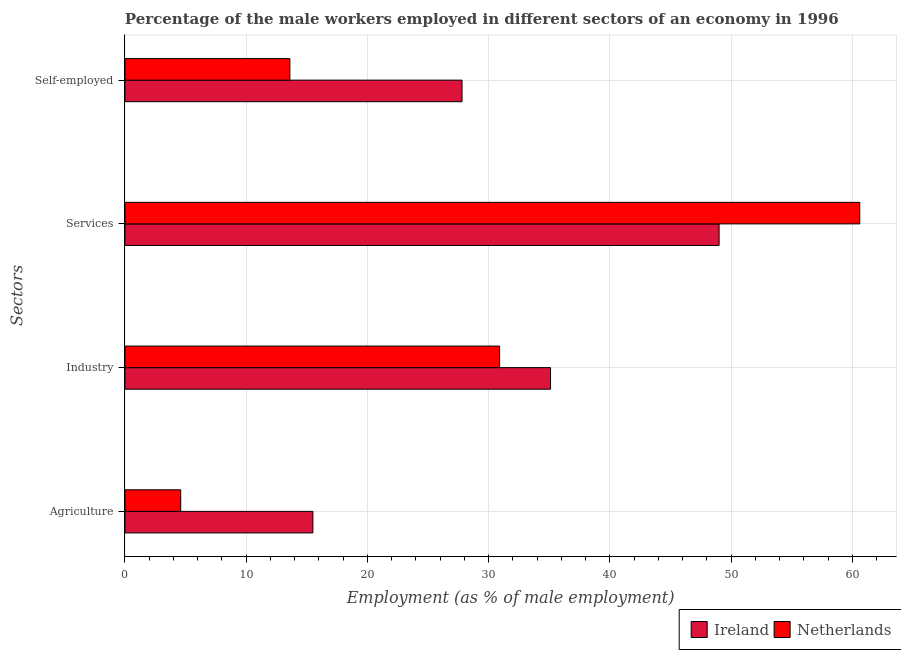Are the number of bars per tick equal to the number of legend labels?
Make the answer very short. Yes. What is the label of the 1st group of bars from the top?
Your answer should be compact. Self-employed. What is the percentage of male workers in agriculture in Ireland?
Make the answer very short. 15.5. Across all countries, what is the maximum percentage of male workers in agriculture?
Keep it short and to the point. 15.5. Across all countries, what is the minimum percentage of self employed male workers?
Ensure brevity in your answer.  13.6. In which country was the percentage of male workers in services maximum?
Your response must be concise. Netherlands. In which country was the percentage of male workers in services minimum?
Your answer should be compact. Ireland. What is the total percentage of male workers in industry in the graph?
Your answer should be very brief. 66. What is the difference between the percentage of male workers in services in Ireland and that in Netherlands?
Offer a very short reply. -11.6. What is the difference between the percentage of male workers in industry in Netherlands and the percentage of self employed male workers in Ireland?
Provide a short and direct response. 3.1. What is the average percentage of male workers in agriculture per country?
Your answer should be compact. 10.05. What is the difference between the percentage of male workers in services and percentage of male workers in agriculture in Netherlands?
Provide a short and direct response. 56. In how many countries, is the percentage of male workers in services greater than 16 %?
Make the answer very short. 2. What is the ratio of the percentage of male workers in industry in Ireland to that in Netherlands?
Your answer should be very brief. 1.14. Is the percentage of male workers in services in Netherlands less than that in Ireland?
Make the answer very short. No. What is the difference between the highest and the second highest percentage of male workers in services?
Your answer should be compact. 11.6. What is the difference between the highest and the lowest percentage of male workers in services?
Offer a terse response. 11.6. In how many countries, is the percentage of male workers in industry greater than the average percentage of male workers in industry taken over all countries?
Offer a terse response. 1. What does the 2nd bar from the bottom in Services represents?
Ensure brevity in your answer.  Netherlands. How many bars are there?
Offer a terse response. 8. How many countries are there in the graph?
Provide a short and direct response. 2. Does the graph contain grids?
Your answer should be very brief. Yes. Where does the legend appear in the graph?
Make the answer very short. Bottom right. How many legend labels are there?
Keep it short and to the point. 2. How are the legend labels stacked?
Your answer should be compact. Horizontal. What is the title of the graph?
Offer a terse response. Percentage of the male workers employed in different sectors of an economy in 1996. Does "Seychelles" appear as one of the legend labels in the graph?
Give a very brief answer. No. What is the label or title of the X-axis?
Offer a very short reply. Employment (as % of male employment). What is the label or title of the Y-axis?
Your answer should be very brief. Sectors. What is the Employment (as % of male employment) of Netherlands in Agriculture?
Provide a short and direct response. 4.6. What is the Employment (as % of male employment) of Ireland in Industry?
Offer a terse response. 35.1. What is the Employment (as % of male employment) in Netherlands in Industry?
Offer a terse response. 30.9. What is the Employment (as % of male employment) of Netherlands in Services?
Make the answer very short. 60.6. What is the Employment (as % of male employment) of Ireland in Self-employed?
Your answer should be very brief. 27.8. What is the Employment (as % of male employment) of Netherlands in Self-employed?
Your answer should be compact. 13.6. Across all Sectors, what is the maximum Employment (as % of male employment) of Ireland?
Provide a short and direct response. 49. Across all Sectors, what is the maximum Employment (as % of male employment) in Netherlands?
Offer a terse response. 60.6. Across all Sectors, what is the minimum Employment (as % of male employment) of Ireland?
Provide a succinct answer. 15.5. Across all Sectors, what is the minimum Employment (as % of male employment) in Netherlands?
Provide a short and direct response. 4.6. What is the total Employment (as % of male employment) of Ireland in the graph?
Give a very brief answer. 127.4. What is the total Employment (as % of male employment) of Netherlands in the graph?
Give a very brief answer. 109.7. What is the difference between the Employment (as % of male employment) of Ireland in Agriculture and that in Industry?
Keep it short and to the point. -19.6. What is the difference between the Employment (as % of male employment) in Netherlands in Agriculture and that in Industry?
Your answer should be very brief. -26.3. What is the difference between the Employment (as % of male employment) in Ireland in Agriculture and that in Services?
Ensure brevity in your answer.  -33.5. What is the difference between the Employment (as % of male employment) of Netherlands in Agriculture and that in Services?
Your response must be concise. -56. What is the difference between the Employment (as % of male employment) in Ireland in Agriculture and that in Self-employed?
Ensure brevity in your answer.  -12.3. What is the difference between the Employment (as % of male employment) in Netherlands in Agriculture and that in Self-employed?
Your answer should be very brief. -9. What is the difference between the Employment (as % of male employment) of Netherlands in Industry and that in Services?
Your answer should be compact. -29.7. What is the difference between the Employment (as % of male employment) in Ireland in Industry and that in Self-employed?
Make the answer very short. 7.3. What is the difference between the Employment (as % of male employment) in Netherlands in Industry and that in Self-employed?
Provide a short and direct response. 17.3. What is the difference between the Employment (as % of male employment) in Ireland in Services and that in Self-employed?
Offer a terse response. 21.2. What is the difference between the Employment (as % of male employment) of Ireland in Agriculture and the Employment (as % of male employment) of Netherlands in Industry?
Your answer should be very brief. -15.4. What is the difference between the Employment (as % of male employment) of Ireland in Agriculture and the Employment (as % of male employment) of Netherlands in Services?
Offer a very short reply. -45.1. What is the difference between the Employment (as % of male employment) of Ireland in Industry and the Employment (as % of male employment) of Netherlands in Services?
Keep it short and to the point. -25.5. What is the difference between the Employment (as % of male employment) of Ireland in Industry and the Employment (as % of male employment) of Netherlands in Self-employed?
Give a very brief answer. 21.5. What is the difference between the Employment (as % of male employment) in Ireland in Services and the Employment (as % of male employment) in Netherlands in Self-employed?
Your response must be concise. 35.4. What is the average Employment (as % of male employment) of Ireland per Sectors?
Make the answer very short. 31.85. What is the average Employment (as % of male employment) in Netherlands per Sectors?
Offer a terse response. 27.43. What is the difference between the Employment (as % of male employment) of Ireland and Employment (as % of male employment) of Netherlands in Agriculture?
Your response must be concise. 10.9. What is the ratio of the Employment (as % of male employment) in Ireland in Agriculture to that in Industry?
Offer a very short reply. 0.44. What is the ratio of the Employment (as % of male employment) of Netherlands in Agriculture to that in Industry?
Make the answer very short. 0.15. What is the ratio of the Employment (as % of male employment) of Ireland in Agriculture to that in Services?
Offer a terse response. 0.32. What is the ratio of the Employment (as % of male employment) in Netherlands in Agriculture to that in Services?
Ensure brevity in your answer.  0.08. What is the ratio of the Employment (as % of male employment) in Ireland in Agriculture to that in Self-employed?
Keep it short and to the point. 0.56. What is the ratio of the Employment (as % of male employment) in Netherlands in Agriculture to that in Self-employed?
Provide a succinct answer. 0.34. What is the ratio of the Employment (as % of male employment) of Ireland in Industry to that in Services?
Offer a very short reply. 0.72. What is the ratio of the Employment (as % of male employment) of Netherlands in Industry to that in Services?
Your answer should be very brief. 0.51. What is the ratio of the Employment (as % of male employment) in Ireland in Industry to that in Self-employed?
Make the answer very short. 1.26. What is the ratio of the Employment (as % of male employment) in Netherlands in Industry to that in Self-employed?
Your response must be concise. 2.27. What is the ratio of the Employment (as % of male employment) in Ireland in Services to that in Self-employed?
Ensure brevity in your answer.  1.76. What is the ratio of the Employment (as % of male employment) of Netherlands in Services to that in Self-employed?
Offer a terse response. 4.46. What is the difference between the highest and the second highest Employment (as % of male employment) in Netherlands?
Provide a succinct answer. 29.7. What is the difference between the highest and the lowest Employment (as % of male employment) in Ireland?
Keep it short and to the point. 33.5. 